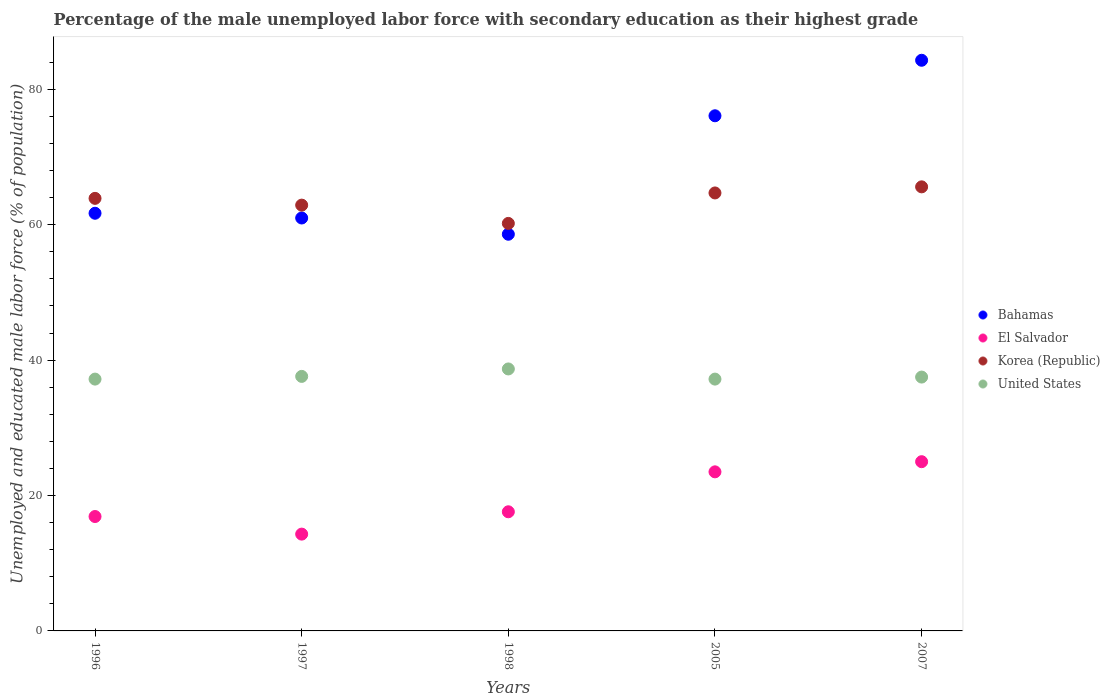What is the percentage of the unemployed male labor force with secondary education in El Salvador in 1997?
Offer a very short reply. 14.3. Across all years, what is the maximum percentage of the unemployed male labor force with secondary education in Korea (Republic)?
Offer a terse response. 65.6. Across all years, what is the minimum percentage of the unemployed male labor force with secondary education in Korea (Republic)?
Your response must be concise. 60.2. What is the total percentage of the unemployed male labor force with secondary education in El Salvador in the graph?
Offer a terse response. 97.3. What is the difference between the percentage of the unemployed male labor force with secondary education in United States in 1996 and that in 2005?
Your answer should be very brief. 0. What is the difference between the percentage of the unemployed male labor force with secondary education in United States in 1998 and the percentage of the unemployed male labor force with secondary education in El Salvador in 2005?
Offer a terse response. 15.2. What is the average percentage of the unemployed male labor force with secondary education in Korea (Republic) per year?
Your response must be concise. 63.46. In the year 2007, what is the difference between the percentage of the unemployed male labor force with secondary education in Bahamas and percentage of the unemployed male labor force with secondary education in El Salvador?
Your answer should be very brief. 59.3. What is the ratio of the percentage of the unemployed male labor force with secondary education in El Salvador in 1998 to that in 2007?
Provide a short and direct response. 0.7. Is the difference between the percentage of the unemployed male labor force with secondary education in Bahamas in 1997 and 2007 greater than the difference between the percentage of the unemployed male labor force with secondary education in El Salvador in 1997 and 2007?
Your answer should be very brief. No. What is the difference between the highest and the second highest percentage of the unemployed male labor force with secondary education in United States?
Provide a short and direct response. 1.1. What is the difference between the highest and the lowest percentage of the unemployed male labor force with secondary education in Bahamas?
Give a very brief answer. 25.7. In how many years, is the percentage of the unemployed male labor force with secondary education in Korea (Republic) greater than the average percentage of the unemployed male labor force with secondary education in Korea (Republic) taken over all years?
Offer a terse response. 3. Is the sum of the percentage of the unemployed male labor force with secondary education in Korea (Republic) in 1998 and 2007 greater than the maximum percentage of the unemployed male labor force with secondary education in Bahamas across all years?
Provide a succinct answer. Yes. Does the percentage of the unemployed male labor force with secondary education in Bahamas monotonically increase over the years?
Provide a succinct answer. No. Is the percentage of the unemployed male labor force with secondary education in El Salvador strictly greater than the percentage of the unemployed male labor force with secondary education in United States over the years?
Your answer should be very brief. No. How many dotlines are there?
Keep it short and to the point. 4. How many years are there in the graph?
Provide a succinct answer. 5. Does the graph contain any zero values?
Provide a succinct answer. No. Where does the legend appear in the graph?
Offer a terse response. Center right. How many legend labels are there?
Your answer should be compact. 4. What is the title of the graph?
Your answer should be compact. Percentage of the male unemployed labor force with secondary education as their highest grade. What is the label or title of the Y-axis?
Offer a terse response. Unemployed and educated male labor force (% of population). What is the Unemployed and educated male labor force (% of population) of Bahamas in 1996?
Provide a short and direct response. 61.7. What is the Unemployed and educated male labor force (% of population) in El Salvador in 1996?
Ensure brevity in your answer.  16.9. What is the Unemployed and educated male labor force (% of population) in Korea (Republic) in 1996?
Keep it short and to the point. 63.9. What is the Unemployed and educated male labor force (% of population) of United States in 1996?
Your answer should be compact. 37.2. What is the Unemployed and educated male labor force (% of population) in Bahamas in 1997?
Your answer should be very brief. 61. What is the Unemployed and educated male labor force (% of population) of El Salvador in 1997?
Your response must be concise. 14.3. What is the Unemployed and educated male labor force (% of population) of Korea (Republic) in 1997?
Your response must be concise. 62.9. What is the Unemployed and educated male labor force (% of population) in United States in 1997?
Offer a terse response. 37.6. What is the Unemployed and educated male labor force (% of population) of Bahamas in 1998?
Provide a succinct answer. 58.6. What is the Unemployed and educated male labor force (% of population) in El Salvador in 1998?
Provide a succinct answer. 17.6. What is the Unemployed and educated male labor force (% of population) in Korea (Republic) in 1998?
Provide a short and direct response. 60.2. What is the Unemployed and educated male labor force (% of population) of United States in 1998?
Give a very brief answer. 38.7. What is the Unemployed and educated male labor force (% of population) of Bahamas in 2005?
Provide a short and direct response. 76.1. What is the Unemployed and educated male labor force (% of population) of El Salvador in 2005?
Keep it short and to the point. 23.5. What is the Unemployed and educated male labor force (% of population) in Korea (Republic) in 2005?
Give a very brief answer. 64.7. What is the Unemployed and educated male labor force (% of population) in United States in 2005?
Your answer should be very brief. 37.2. What is the Unemployed and educated male labor force (% of population) in Bahamas in 2007?
Your response must be concise. 84.3. What is the Unemployed and educated male labor force (% of population) in El Salvador in 2007?
Your answer should be compact. 25. What is the Unemployed and educated male labor force (% of population) of Korea (Republic) in 2007?
Offer a terse response. 65.6. What is the Unemployed and educated male labor force (% of population) of United States in 2007?
Keep it short and to the point. 37.5. Across all years, what is the maximum Unemployed and educated male labor force (% of population) of Bahamas?
Offer a terse response. 84.3. Across all years, what is the maximum Unemployed and educated male labor force (% of population) of El Salvador?
Make the answer very short. 25. Across all years, what is the maximum Unemployed and educated male labor force (% of population) in Korea (Republic)?
Provide a short and direct response. 65.6. Across all years, what is the maximum Unemployed and educated male labor force (% of population) in United States?
Your answer should be compact. 38.7. Across all years, what is the minimum Unemployed and educated male labor force (% of population) in Bahamas?
Your answer should be compact. 58.6. Across all years, what is the minimum Unemployed and educated male labor force (% of population) of El Salvador?
Offer a terse response. 14.3. Across all years, what is the minimum Unemployed and educated male labor force (% of population) of Korea (Republic)?
Your answer should be compact. 60.2. Across all years, what is the minimum Unemployed and educated male labor force (% of population) in United States?
Your answer should be very brief. 37.2. What is the total Unemployed and educated male labor force (% of population) of Bahamas in the graph?
Your answer should be very brief. 341.7. What is the total Unemployed and educated male labor force (% of population) of El Salvador in the graph?
Your response must be concise. 97.3. What is the total Unemployed and educated male labor force (% of population) of Korea (Republic) in the graph?
Give a very brief answer. 317.3. What is the total Unemployed and educated male labor force (% of population) in United States in the graph?
Your response must be concise. 188.2. What is the difference between the Unemployed and educated male labor force (% of population) in Bahamas in 1996 and that in 1997?
Ensure brevity in your answer.  0.7. What is the difference between the Unemployed and educated male labor force (% of population) in El Salvador in 1996 and that in 1997?
Offer a very short reply. 2.6. What is the difference between the Unemployed and educated male labor force (% of population) in Korea (Republic) in 1996 and that in 1997?
Give a very brief answer. 1. What is the difference between the Unemployed and educated male labor force (% of population) of Bahamas in 1996 and that in 2005?
Offer a terse response. -14.4. What is the difference between the Unemployed and educated male labor force (% of population) of El Salvador in 1996 and that in 2005?
Make the answer very short. -6.6. What is the difference between the Unemployed and educated male labor force (% of population) of United States in 1996 and that in 2005?
Offer a very short reply. 0. What is the difference between the Unemployed and educated male labor force (% of population) in Bahamas in 1996 and that in 2007?
Offer a very short reply. -22.6. What is the difference between the Unemployed and educated male labor force (% of population) in El Salvador in 1996 and that in 2007?
Your response must be concise. -8.1. What is the difference between the Unemployed and educated male labor force (% of population) in Korea (Republic) in 1996 and that in 2007?
Keep it short and to the point. -1.7. What is the difference between the Unemployed and educated male labor force (% of population) of Bahamas in 1997 and that in 1998?
Offer a very short reply. 2.4. What is the difference between the Unemployed and educated male labor force (% of population) of El Salvador in 1997 and that in 1998?
Ensure brevity in your answer.  -3.3. What is the difference between the Unemployed and educated male labor force (% of population) of United States in 1997 and that in 1998?
Provide a short and direct response. -1.1. What is the difference between the Unemployed and educated male labor force (% of population) of Bahamas in 1997 and that in 2005?
Your response must be concise. -15.1. What is the difference between the Unemployed and educated male labor force (% of population) in United States in 1997 and that in 2005?
Provide a succinct answer. 0.4. What is the difference between the Unemployed and educated male labor force (% of population) of Bahamas in 1997 and that in 2007?
Offer a very short reply. -23.3. What is the difference between the Unemployed and educated male labor force (% of population) of Korea (Republic) in 1997 and that in 2007?
Ensure brevity in your answer.  -2.7. What is the difference between the Unemployed and educated male labor force (% of population) in Bahamas in 1998 and that in 2005?
Make the answer very short. -17.5. What is the difference between the Unemployed and educated male labor force (% of population) of United States in 1998 and that in 2005?
Offer a very short reply. 1.5. What is the difference between the Unemployed and educated male labor force (% of population) in Bahamas in 1998 and that in 2007?
Give a very brief answer. -25.7. What is the difference between the Unemployed and educated male labor force (% of population) of Bahamas in 2005 and that in 2007?
Your response must be concise. -8.2. What is the difference between the Unemployed and educated male labor force (% of population) of Korea (Republic) in 2005 and that in 2007?
Offer a terse response. -0.9. What is the difference between the Unemployed and educated male labor force (% of population) in Bahamas in 1996 and the Unemployed and educated male labor force (% of population) in El Salvador in 1997?
Make the answer very short. 47.4. What is the difference between the Unemployed and educated male labor force (% of population) in Bahamas in 1996 and the Unemployed and educated male labor force (% of population) in United States in 1997?
Make the answer very short. 24.1. What is the difference between the Unemployed and educated male labor force (% of population) of El Salvador in 1996 and the Unemployed and educated male labor force (% of population) of Korea (Republic) in 1997?
Make the answer very short. -46. What is the difference between the Unemployed and educated male labor force (% of population) of El Salvador in 1996 and the Unemployed and educated male labor force (% of population) of United States in 1997?
Your answer should be compact. -20.7. What is the difference between the Unemployed and educated male labor force (% of population) in Korea (Republic) in 1996 and the Unemployed and educated male labor force (% of population) in United States in 1997?
Provide a short and direct response. 26.3. What is the difference between the Unemployed and educated male labor force (% of population) of Bahamas in 1996 and the Unemployed and educated male labor force (% of population) of El Salvador in 1998?
Your response must be concise. 44.1. What is the difference between the Unemployed and educated male labor force (% of population) in Bahamas in 1996 and the Unemployed and educated male labor force (% of population) in Korea (Republic) in 1998?
Make the answer very short. 1.5. What is the difference between the Unemployed and educated male labor force (% of population) in El Salvador in 1996 and the Unemployed and educated male labor force (% of population) in Korea (Republic) in 1998?
Your answer should be compact. -43.3. What is the difference between the Unemployed and educated male labor force (% of population) of El Salvador in 1996 and the Unemployed and educated male labor force (% of population) of United States in 1998?
Give a very brief answer. -21.8. What is the difference between the Unemployed and educated male labor force (% of population) of Korea (Republic) in 1996 and the Unemployed and educated male labor force (% of population) of United States in 1998?
Offer a terse response. 25.2. What is the difference between the Unemployed and educated male labor force (% of population) of Bahamas in 1996 and the Unemployed and educated male labor force (% of population) of El Salvador in 2005?
Provide a short and direct response. 38.2. What is the difference between the Unemployed and educated male labor force (% of population) of Bahamas in 1996 and the Unemployed and educated male labor force (% of population) of United States in 2005?
Ensure brevity in your answer.  24.5. What is the difference between the Unemployed and educated male labor force (% of population) in El Salvador in 1996 and the Unemployed and educated male labor force (% of population) in Korea (Republic) in 2005?
Give a very brief answer. -47.8. What is the difference between the Unemployed and educated male labor force (% of population) in El Salvador in 1996 and the Unemployed and educated male labor force (% of population) in United States in 2005?
Your response must be concise. -20.3. What is the difference between the Unemployed and educated male labor force (% of population) of Korea (Republic) in 1996 and the Unemployed and educated male labor force (% of population) of United States in 2005?
Offer a very short reply. 26.7. What is the difference between the Unemployed and educated male labor force (% of population) of Bahamas in 1996 and the Unemployed and educated male labor force (% of population) of El Salvador in 2007?
Ensure brevity in your answer.  36.7. What is the difference between the Unemployed and educated male labor force (% of population) of Bahamas in 1996 and the Unemployed and educated male labor force (% of population) of Korea (Republic) in 2007?
Your answer should be compact. -3.9. What is the difference between the Unemployed and educated male labor force (% of population) of Bahamas in 1996 and the Unemployed and educated male labor force (% of population) of United States in 2007?
Make the answer very short. 24.2. What is the difference between the Unemployed and educated male labor force (% of population) in El Salvador in 1996 and the Unemployed and educated male labor force (% of population) in Korea (Republic) in 2007?
Make the answer very short. -48.7. What is the difference between the Unemployed and educated male labor force (% of population) of El Salvador in 1996 and the Unemployed and educated male labor force (% of population) of United States in 2007?
Make the answer very short. -20.6. What is the difference between the Unemployed and educated male labor force (% of population) of Korea (Republic) in 1996 and the Unemployed and educated male labor force (% of population) of United States in 2007?
Give a very brief answer. 26.4. What is the difference between the Unemployed and educated male labor force (% of population) in Bahamas in 1997 and the Unemployed and educated male labor force (% of population) in El Salvador in 1998?
Make the answer very short. 43.4. What is the difference between the Unemployed and educated male labor force (% of population) in Bahamas in 1997 and the Unemployed and educated male labor force (% of population) in United States in 1998?
Your answer should be compact. 22.3. What is the difference between the Unemployed and educated male labor force (% of population) in El Salvador in 1997 and the Unemployed and educated male labor force (% of population) in Korea (Republic) in 1998?
Your answer should be compact. -45.9. What is the difference between the Unemployed and educated male labor force (% of population) of El Salvador in 1997 and the Unemployed and educated male labor force (% of population) of United States in 1998?
Offer a very short reply. -24.4. What is the difference between the Unemployed and educated male labor force (% of population) in Korea (Republic) in 1997 and the Unemployed and educated male labor force (% of population) in United States in 1998?
Your answer should be very brief. 24.2. What is the difference between the Unemployed and educated male labor force (% of population) of Bahamas in 1997 and the Unemployed and educated male labor force (% of population) of El Salvador in 2005?
Offer a terse response. 37.5. What is the difference between the Unemployed and educated male labor force (% of population) of Bahamas in 1997 and the Unemployed and educated male labor force (% of population) of Korea (Republic) in 2005?
Keep it short and to the point. -3.7. What is the difference between the Unemployed and educated male labor force (% of population) of Bahamas in 1997 and the Unemployed and educated male labor force (% of population) of United States in 2005?
Offer a terse response. 23.8. What is the difference between the Unemployed and educated male labor force (% of population) of El Salvador in 1997 and the Unemployed and educated male labor force (% of population) of Korea (Republic) in 2005?
Offer a terse response. -50.4. What is the difference between the Unemployed and educated male labor force (% of population) of El Salvador in 1997 and the Unemployed and educated male labor force (% of population) of United States in 2005?
Make the answer very short. -22.9. What is the difference between the Unemployed and educated male labor force (% of population) in Korea (Republic) in 1997 and the Unemployed and educated male labor force (% of population) in United States in 2005?
Provide a succinct answer. 25.7. What is the difference between the Unemployed and educated male labor force (% of population) in El Salvador in 1997 and the Unemployed and educated male labor force (% of population) in Korea (Republic) in 2007?
Your answer should be compact. -51.3. What is the difference between the Unemployed and educated male labor force (% of population) of El Salvador in 1997 and the Unemployed and educated male labor force (% of population) of United States in 2007?
Your answer should be very brief. -23.2. What is the difference between the Unemployed and educated male labor force (% of population) in Korea (Republic) in 1997 and the Unemployed and educated male labor force (% of population) in United States in 2007?
Your answer should be compact. 25.4. What is the difference between the Unemployed and educated male labor force (% of population) in Bahamas in 1998 and the Unemployed and educated male labor force (% of population) in El Salvador in 2005?
Your answer should be very brief. 35.1. What is the difference between the Unemployed and educated male labor force (% of population) of Bahamas in 1998 and the Unemployed and educated male labor force (% of population) of Korea (Republic) in 2005?
Ensure brevity in your answer.  -6.1. What is the difference between the Unemployed and educated male labor force (% of population) in Bahamas in 1998 and the Unemployed and educated male labor force (% of population) in United States in 2005?
Give a very brief answer. 21.4. What is the difference between the Unemployed and educated male labor force (% of population) in El Salvador in 1998 and the Unemployed and educated male labor force (% of population) in Korea (Republic) in 2005?
Your response must be concise. -47.1. What is the difference between the Unemployed and educated male labor force (% of population) in El Salvador in 1998 and the Unemployed and educated male labor force (% of population) in United States in 2005?
Offer a very short reply. -19.6. What is the difference between the Unemployed and educated male labor force (% of population) in Korea (Republic) in 1998 and the Unemployed and educated male labor force (% of population) in United States in 2005?
Your answer should be very brief. 23. What is the difference between the Unemployed and educated male labor force (% of population) in Bahamas in 1998 and the Unemployed and educated male labor force (% of population) in El Salvador in 2007?
Your answer should be very brief. 33.6. What is the difference between the Unemployed and educated male labor force (% of population) of Bahamas in 1998 and the Unemployed and educated male labor force (% of population) of Korea (Republic) in 2007?
Give a very brief answer. -7. What is the difference between the Unemployed and educated male labor force (% of population) of Bahamas in 1998 and the Unemployed and educated male labor force (% of population) of United States in 2007?
Give a very brief answer. 21.1. What is the difference between the Unemployed and educated male labor force (% of population) in El Salvador in 1998 and the Unemployed and educated male labor force (% of population) in Korea (Republic) in 2007?
Your response must be concise. -48. What is the difference between the Unemployed and educated male labor force (% of population) of El Salvador in 1998 and the Unemployed and educated male labor force (% of population) of United States in 2007?
Provide a short and direct response. -19.9. What is the difference between the Unemployed and educated male labor force (% of population) of Korea (Republic) in 1998 and the Unemployed and educated male labor force (% of population) of United States in 2007?
Provide a succinct answer. 22.7. What is the difference between the Unemployed and educated male labor force (% of population) of Bahamas in 2005 and the Unemployed and educated male labor force (% of population) of El Salvador in 2007?
Make the answer very short. 51.1. What is the difference between the Unemployed and educated male labor force (% of population) of Bahamas in 2005 and the Unemployed and educated male labor force (% of population) of Korea (Republic) in 2007?
Provide a short and direct response. 10.5. What is the difference between the Unemployed and educated male labor force (% of population) of Bahamas in 2005 and the Unemployed and educated male labor force (% of population) of United States in 2007?
Your answer should be compact. 38.6. What is the difference between the Unemployed and educated male labor force (% of population) of El Salvador in 2005 and the Unemployed and educated male labor force (% of population) of Korea (Republic) in 2007?
Offer a terse response. -42.1. What is the difference between the Unemployed and educated male labor force (% of population) in Korea (Republic) in 2005 and the Unemployed and educated male labor force (% of population) in United States in 2007?
Make the answer very short. 27.2. What is the average Unemployed and educated male labor force (% of population) in Bahamas per year?
Your answer should be compact. 68.34. What is the average Unemployed and educated male labor force (% of population) of El Salvador per year?
Provide a succinct answer. 19.46. What is the average Unemployed and educated male labor force (% of population) of Korea (Republic) per year?
Your answer should be compact. 63.46. What is the average Unemployed and educated male labor force (% of population) in United States per year?
Make the answer very short. 37.64. In the year 1996, what is the difference between the Unemployed and educated male labor force (% of population) in Bahamas and Unemployed and educated male labor force (% of population) in El Salvador?
Provide a short and direct response. 44.8. In the year 1996, what is the difference between the Unemployed and educated male labor force (% of population) in Bahamas and Unemployed and educated male labor force (% of population) in Korea (Republic)?
Provide a succinct answer. -2.2. In the year 1996, what is the difference between the Unemployed and educated male labor force (% of population) of Bahamas and Unemployed and educated male labor force (% of population) of United States?
Offer a terse response. 24.5. In the year 1996, what is the difference between the Unemployed and educated male labor force (% of population) in El Salvador and Unemployed and educated male labor force (% of population) in Korea (Republic)?
Provide a succinct answer. -47. In the year 1996, what is the difference between the Unemployed and educated male labor force (% of population) in El Salvador and Unemployed and educated male labor force (% of population) in United States?
Give a very brief answer. -20.3. In the year 1996, what is the difference between the Unemployed and educated male labor force (% of population) of Korea (Republic) and Unemployed and educated male labor force (% of population) of United States?
Offer a terse response. 26.7. In the year 1997, what is the difference between the Unemployed and educated male labor force (% of population) of Bahamas and Unemployed and educated male labor force (% of population) of El Salvador?
Give a very brief answer. 46.7. In the year 1997, what is the difference between the Unemployed and educated male labor force (% of population) of Bahamas and Unemployed and educated male labor force (% of population) of Korea (Republic)?
Your response must be concise. -1.9. In the year 1997, what is the difference between the Unemployed and educated male labor force (% of population) of Bahamas and Unemployed and educated male labor force (% of population) of United States?
Provide a short and direct response. 23.4. In the year 1997, what is the difference between the Unemployed and educated male labor force (% of population) in El Salvador and Unemployed and educated male labor force (% of population) in Korea (Republic)?
Give a very brief answer. -48.6. In the year 1997, what is the difference between the Unemployed and educated male labor force (% of population) of El Salvador and Unemployed and educated male labor force (% of population) of United States?
Your answer should be very brief. -23.3. In the year 1997, what is the difference between the Unemployed and educated male labor force (% of population) of Korea (Republic) and Unemployed and educated male labor force (% of population) of United States?
Offer a terse response. 25.3. In the year 1998, what is the difference between the Unemployed and educated male labor force (% of population) in Bahamas and Unemployed and educated male labor force (% of population) in Korea (Republic)?
Your answer should be very brief. -1.6. In the year 1998, what is the difference between the Unemployed and educated male labor force (% of population) of Bahamas and Unemployed and educated male labor force (% of population) of United States?
Provide a succinct answer. 19.9. In the year 1998, what is the difference between the Unemployed and educated male labor force (% of population) in El Salvador and Unemployed and educated male labor force (% of population) in Korea (Republic)?
Offer a very short reply. -42.6. In the year 1998, what is the difference between the Unemployed and educated male labor force (% of population) in El Salvador and Unemployed and educated male labor force (% of population) in United States?
Your response must be concise. -21.1. In the year 1998, what is the difference between the Unemployed and educated male labor force (% of population) of Korea (Republic) and Unemployed and educated male labor force (% of population) of United States?
Your answer should be compact. 21.5. In the year 2005, what is the difference between the Unemployed and educated male labor force (% of population) of Bahamas and Unemployed and educated male labor force (% of population) of El Salvador?
Provide a short and direct response. 52.6. In the year 2005, what is the difference between the Unemployed and educated male labor force (% of population) of Bahamas and Unemployed and educated male labor force (% of population) of Korea (Republic)?
Offer a very short reply. 11.4. In the year 2005, what is the difference between the Unemployed and educated male labor force (% of population) of Bahamas and Unemployed and educated male labor force (% of population) of United States?
Make the answer very short. 38.9. In the year 2005, what is the difference between the Unemployed and educated male labor force (% of population) in El Salvador and Unemployed and educated male labor force (% of population) in Korea (Republic)?
Keep it short and to the point. -41.2. In the year 2005, what is the difference between the Unemployed and educated male labor force (% of population) in El Salvador and Unemployed and educated male labor force (% of population) in United States?
Your answer should be very brief. -13.7. In the year 2007, what is the difference between the Unemployed and educated male labor force (% of population) of Bahamas and Unemployed and educated male labor force (% of population) of El Salvador?
Give a very brief answer. 59.3. In the year 2007, what is the difference between the Unemployed and educated male labor force (% of population) in Bahamas and Unemployed and educated male labor force (% of population) in United States?
Provide a succinct answer. 46.8. In the year 2007, what is the difference between the Unemployed and educated male labor force (% of population) of El Salvador and Unemployed and educated male labor force (% of population) of Korea (Republic)?
Keep it short and to the point. -40.6. In the year 2007, what is the difference between the Unemployed and educated male labor force (% of population) in El Salvador and Unemployed and educated male labor force (% of population) in United States?
Provide a succinct answer. -12.5. In the year 2007, what is the difference between the Unemployed and educated male labor force (% of population) in Korea (Republic) and Unemployed and educated male labor force (% of population) in United States?
Provide a succinct answer. 28.1. What is the ratio of the Unemployed and educated male labor force (% of population) of Bahamas in 1996 to that in 1997?
Your answer should be very brief. 1.01. What is the ratio of the Unemployed and educated male labor force (% of population) of El Salvador in 1996 to that in 1997?
Provide a succinct answer. 1.18. What is the ratio of the Unemployed and educated male labor force (% of population) in Korea (Republic) in 1996 to that in 1997?
Your answer should be compact. 1.02. What is the ratio of the Unemployed and educated male labor force (% of population) of Bahamas in 1996 to that in 1998?
Provide a short and direct response. 1.05. What is the ratio of the Unemployed and educated male labor force (% of population) in El Salvador in 1996 to that in 1998?
Your response must be concise. 0.96. What is the ratio of the Unemployed and educated male labor force (% of population) of Korea (Republic) in 1996 to that in 1998?
Make the answer very short. 1.06. What is the ratio of the Unemployed and educated male labor force (% of population) in United States in 1996 to that in 1998?
Provide a short and direct response. 0.96. What is the ratio of the Unemployed and educated male labor force (% of population) in Bahamas in 1996 to that in 2005?
Ensure brevity in your answer.  0.81. What is the ratio of the Unemployed and educated male labor force (% of population) of El Salvador in 1996 to that in 2005?
Offer a terse response. 0.72. What is the ratio of the Unemployed and educated male labor force (% of population) in Korea (Republic) in 1996 to that in 2005?
Offer a terse response. 0.99. What is the ratio of the Unemployed and educated male labor force (% of population) of United States in 1996 to that in 2005?
Make the answer very short. 1. What is the ratio of the Unemployed and educated male labor force (% of population) of Bahamas in 1996 to that in 2007?
Provide a short and direct response. 0.73. What is the ratio of the Unemployed and educated male labor force (% of population) in El Salvador in 1996 to that in 2007?
Keep it short and to the point. 0.68. What is the ratio of the Unemployed and educated male labor force (% of population) of Korea (Republic) in 1996 to that in 2007?
Keep it short and to the point. 0.97. What is the ratio of the Unemployed and educated male labor force (% of population) in United States in 1996 to that in 2007?
Provide a short and direct response. 0.99. What is the ratio of the Unemployed and educated male labor force (% of population) of Bahamas in 1997 to that in 1998?
Offer a terse response. 1.04. What is the ratio of the Unemployed and educated male labor force (% of population) of El Salvador in 1997 to that in 1998?
Your answer should be very brief. 0.81. What is the ratio of the Unemployed and educated male labor force (% of population) of Korea (Republic) in 1997 to that in 1998?
Your answer should be very brief. 1.04. What is the ratio of the Unemployed and educated male labor force (% of population) of United States in 1997 to that in 1998?
Offer a terse response. 0.97. What is the ratio of the Unemployed and educated male labor force (% of population) of Bahamas in 1997 to that in 2005?
Provide a succinct answer. 0.8. What is the ratio of the Unemployed and educated male labor force (% of population) in El Salvador in 1997 to that in 2005?
Offer a terse response. 0.61. What is the ratio of the Unemployed and educated male labor force (% of population) of Korea (Republic) in 1997 to that in 2005?
Make the answer very short. 0.97. What is the ratio of the Unemployed and educated male labor force (% of population) of United States in 1997 to that in 2005?
Provide a succinct answer. 1.01. What is the ratio of the Unemployed and educated male labor force (% of population) of Bahamas in 1997 to that in 2007?
Your response must be concise. 0.72. What is the ratio of the Unemployed and educated male labor force (% of population) of El Salvador in 1997 to that in 2007?
Offer a terse response. 0.57. What is the ratio of the Unemployed and educated male labor force (% of population) of Korea (Republic) in 1997 to that in 2007?
Offer a very short reply. 0.96. What is the ratio of the Unemployed and educated male labor force (% of population) of United States in 1997 to that in 2007?
Your answer should be compact. 1. What is the ratio of the Unemployed and educated male labor force (% of population) in Bahamas in 1998 to that in 2005?
Your answer should be compact. 0.77. What is the ratio of the Unemployed and educated male labor force (% of population) in El Salvador in 1998 to that in 2005?
Your answer should be compact. 0.75. What is the ratio of the Unemployed and educated male labor force (% of population) in Korea (Republic) in 1998 to that in 2005?
Your response must be concise. 0.93. What is the ratio of the Unemployed and educated male labor force (% of population) in United States in 1998 to that in 2005?
Offer a terse response. 1.04. What is the ratio of the Unemployed and educated male labor force (% of population) in Bahamas in 1998 to that in 2007?
Ensure brevity in your answer.  0.7. What is the ratio of the Unemployed and educated male labor force (% of population) in El Salvador in 1998 to that in 2007?
Keep it short and to the point. 0.7. What is the ratio of the Unemployed and educated male labor force (% of population) in Korea (Republic) in 1998 to that in 2007?
Your response must be concise. 0.92. What is the ratio of the Unemployed and educated male labor force (% of population) of United States in 1998 to that in 2007?
Your response must be concise. 1.03. What is the ratio of the Unemployed and educated male labor force (% of population) of Bahamas in 2005 to that in 2007?
Your response must be concise. 0.9. What is the ratio of the Unemployed and educated male labor force (% of population) of El Salvador in 2005 to that in 2007?
Offer a terse response. 0.94. What is the ratio of the Unemployed and educated male labor force (% of population) in Korea (Republic) in 2005 to that in 2007?
Keep it short and to the point. 0.99. What is the difference between the highest and the second highest Unemployed and educated male labor force (% of population) of Korea (Republic)?
Offer a very short reply. 0.9. What is the difference between the highest and the lowest Unemployed and educated male labor force (% of population) in Bahamas?
Offer a terse response. 25.7. What is the difference between the highest and the lowest Unemployed and educated male labor force (% of population) in El Salvador?
Provide a succinct answer. 10.7. What is the difference between the highest and the lowest Unemployed and educated male labor force (% of population) of Korea (Republic)?
Offer a terse response. 5.4. What is the difference between the highest and the lowest Unemployed and educated male labor force (% of population) of United States?
Provide a short and direct response. 1.5. 